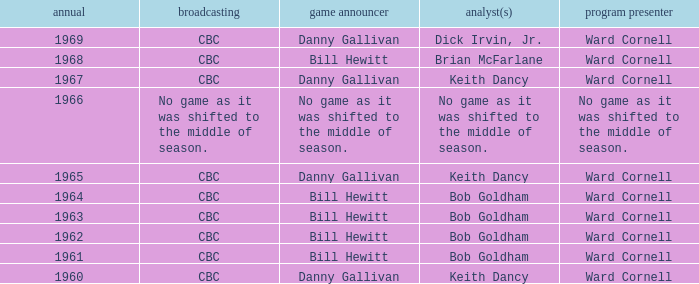Who did the play-by-play on the CBC network before 1961? Danny Gallivan. 